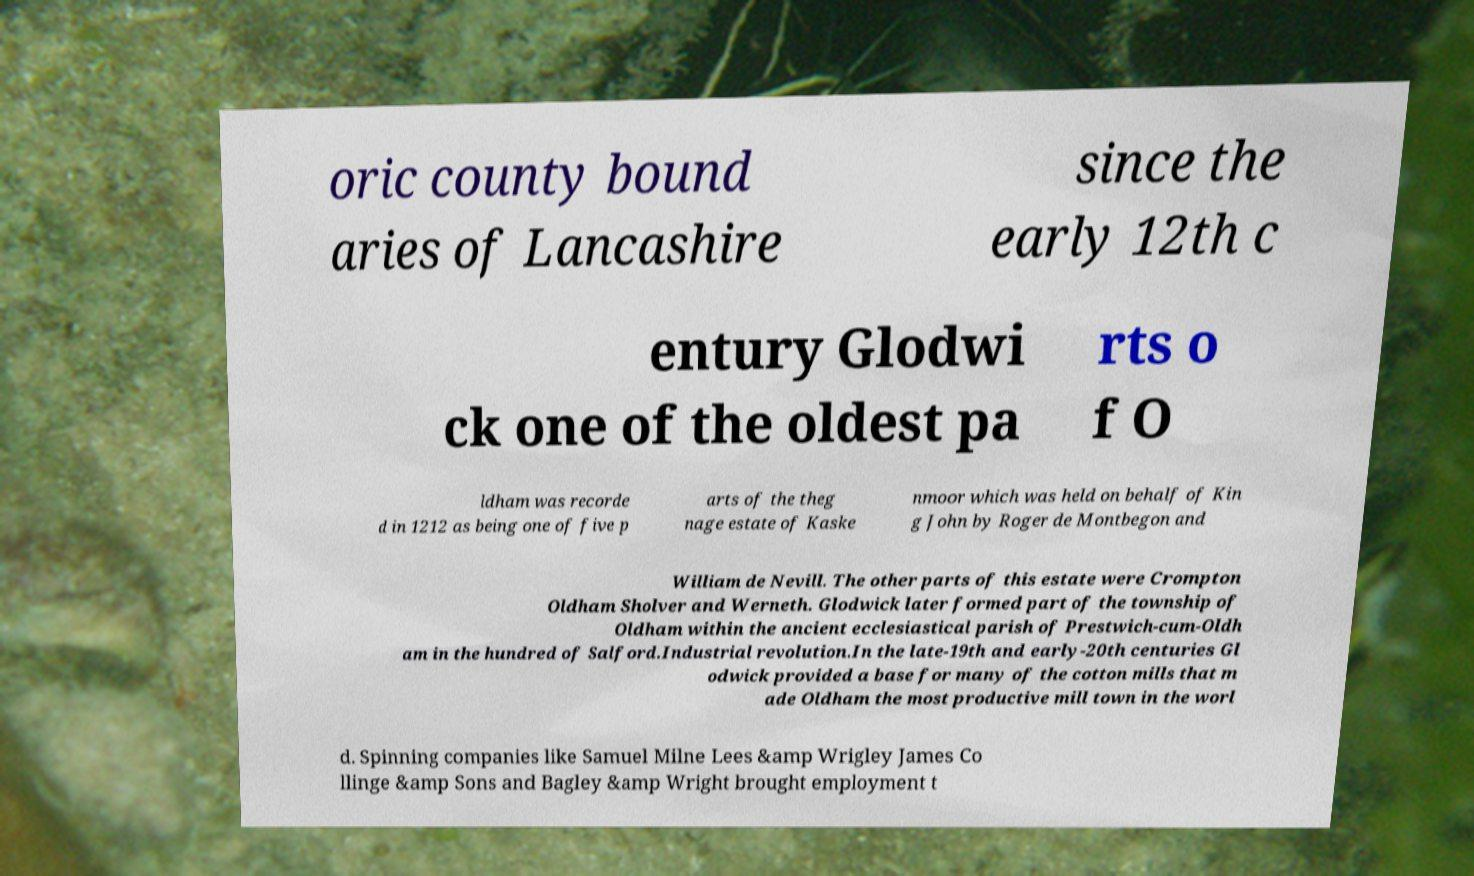Can you read and provide the text displayed in the image?This photo seems to have some interesting text. Can you extract and type it out for me? oric county bound aries of Lancashire since the early 12th c entury Glodwi ck one of the oldest pa rts o f O ldham was recorde d in 1212 as being one of five p arts of the theg nage estate of Kaske nmoor which was held on behalf of Kin g John by Roger de Montbegon and William de Nevill. The other parts of this estate were Crompton Oldham Sholver and Werneth. Glodwick later formed part of the township of Oldham within the ancient ecclesiastical parish of Prestwich-cum-Oldh am in the hundred of Salford.Industrial revolution.In the late-19th and early-20th centuries Gl odwick provided a base for many of the cotton mills that m ade Oldham the most productive mill town in the worl d. Spinning companies like Samuel Milne Lees &amp Wrigley James Co llinge &amp Sons and Bagley &amp Wright brought employment t 